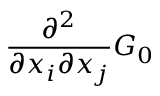<formula> <loc_0><loc_0><loc_500><loc_500>\frac { \partial ^ { 2 } } { \partial x _ { i } \partial x _ { j } } G _ { 0 }</formula> 